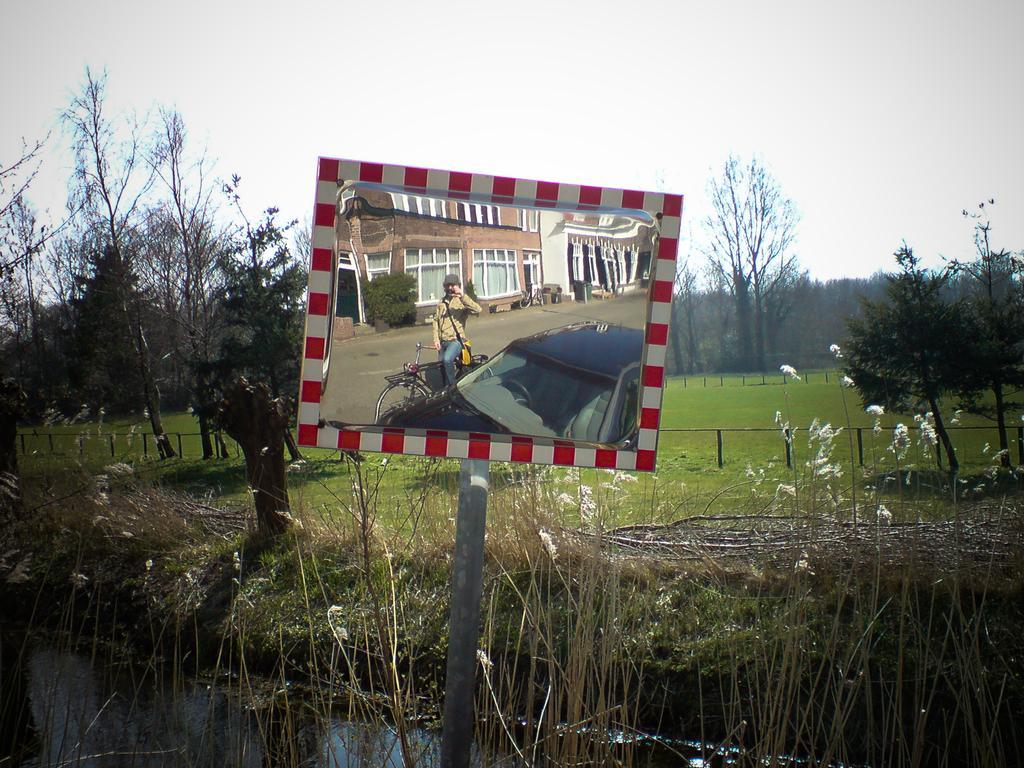Can you describe this image briefly? In the foreground of the image, we can see a pole and board. On the board we can see buildings, car, person, bicycle and road. In the background of the image, we can see grassy land, fence, grass and trees. At the top of the image, we can see the sky. 